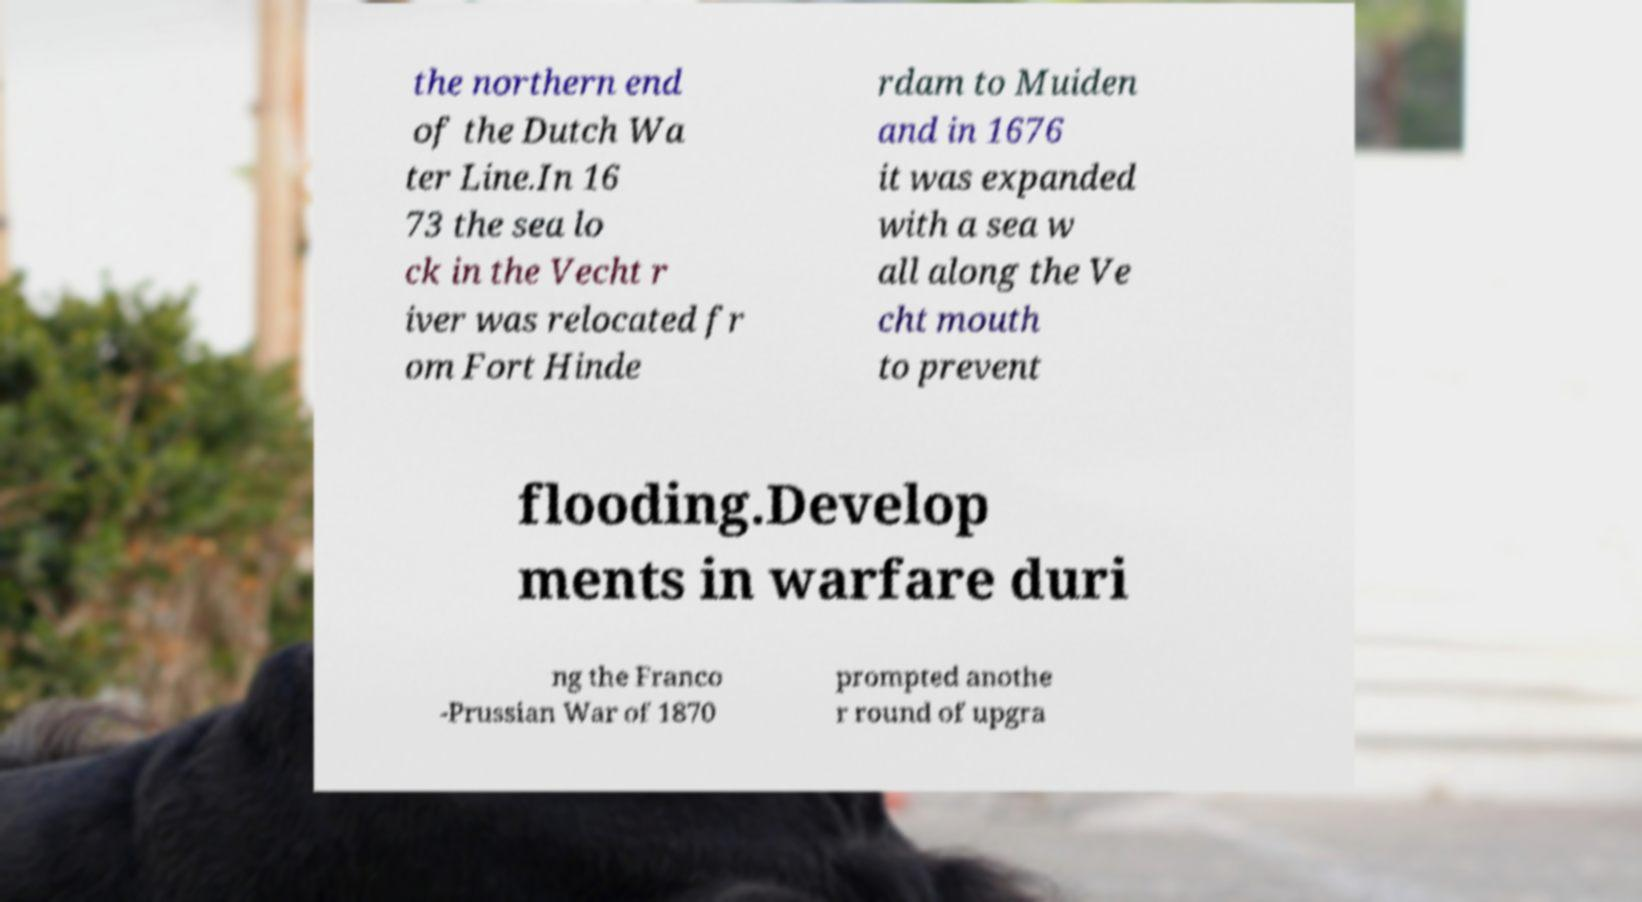Can you read and provide the text displayed in the image?This photo seems to have some interesting text. Can you extract and type it out for me? the northern end of the Dutch Wa ter Line.In 16 73 the sea lo ck in the Vecht r iver was relocated fr om Fort Hinde rdam to Muiden and in 1676 it was expanded with a sea w all along the Ve cht mouth to prevent flooding.Develop ments in warfare duri ng the Franco -Prussian War of 1870 prompted anothe r round of upgra 